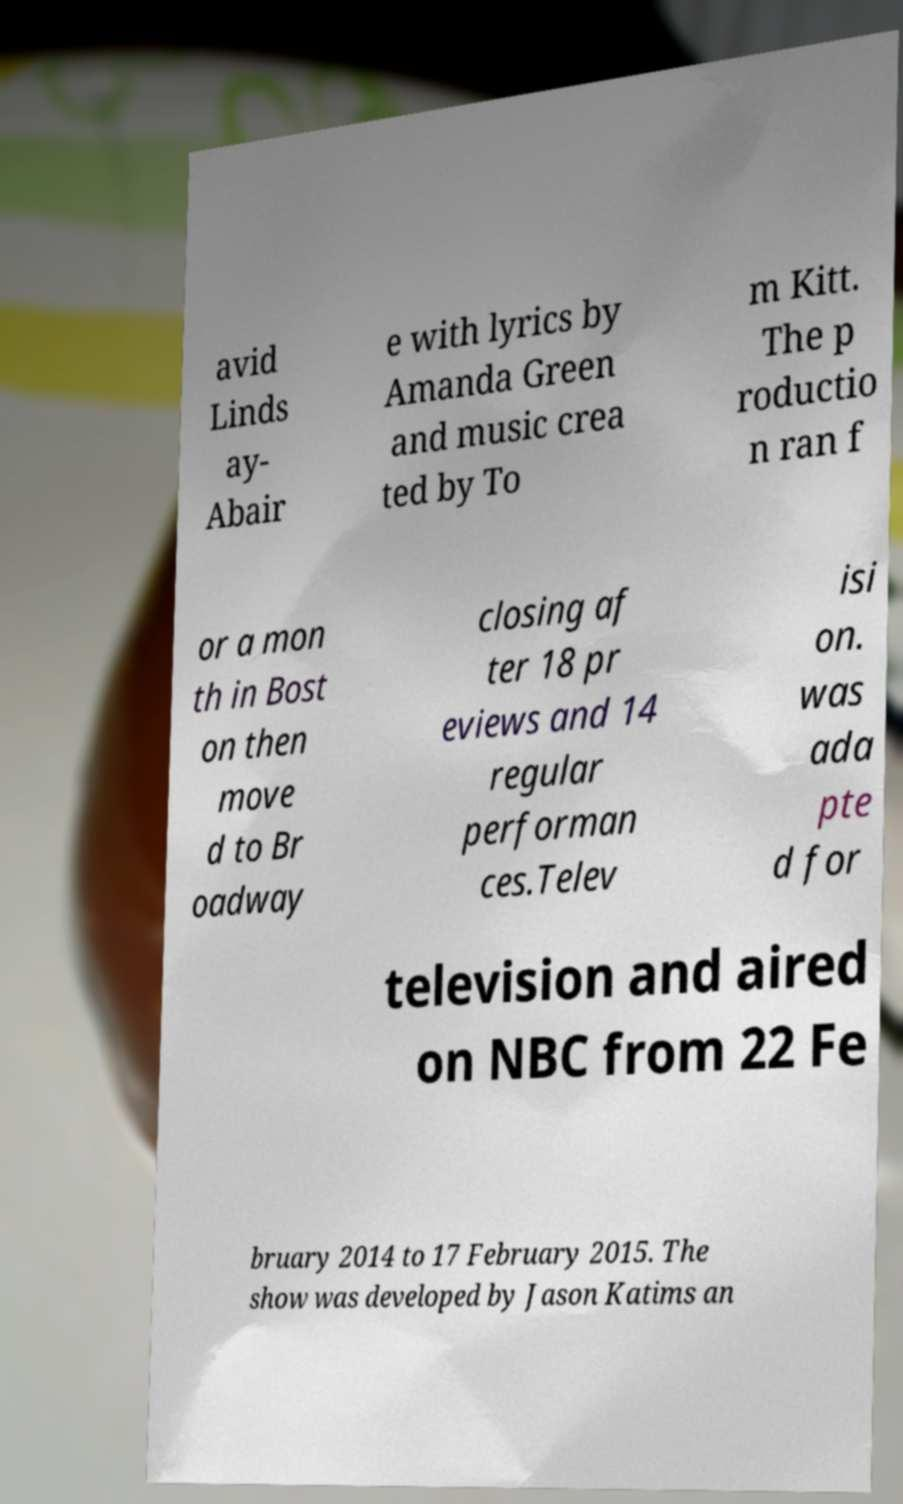Could you assist in decoding the text presented in this image and type it out clearly? avid Linds ay- Abair e with lyrics by Amanda Green and music crea ted by To m Kitt. The p roductio n ran f or a mon th in Bost on then move d to Br oadway closing af ter 18 pr eviews and 14 regular performan ces.Telev isi on. was ada pte d for television and aired on NBC from 22 Fe bruary 2014 to 17 February 2015. The show was developed by Jason Katims an 